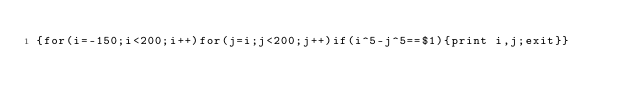<code> <loc_0><loc_0><loc_500><loc_500><_Awk_>{for(i=-150;i<200;i++)for(j=i;j<200;j++)if(i^5-j^5==$1){print i,j;exit}}</code> 